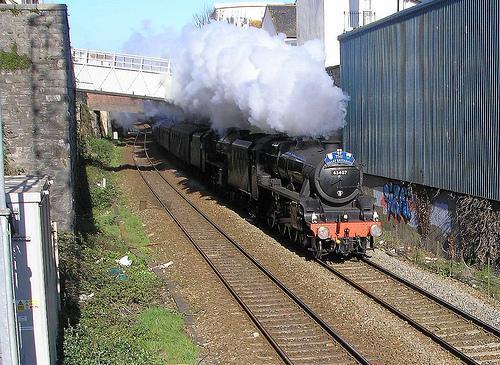How many trains are shown?
Give a very brief answer. 1. How many tracks are there?
Give a very brief answer. 2. 